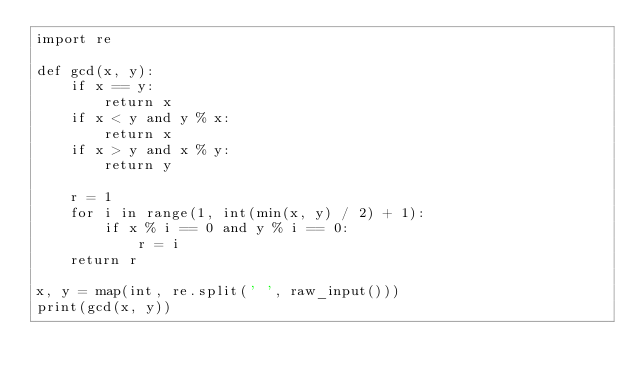Convert code to text. <code><loc_0><loc_0><loc_500><loc_500><_Python_>import re

def gcd(x, y):
    if x == y:
        return x
    if x < y and y % x:
        return x
    if x > y and x % y:
        return y

    r = 1
    for i in range(1, int(min(x, y) / 2) + 1):
        if x % i == 0 and y % i == 0:
            r = i
    return r
 
x, y = map(int, re.split(' ', raw_input()))
print(gcd(x, y))</code> 